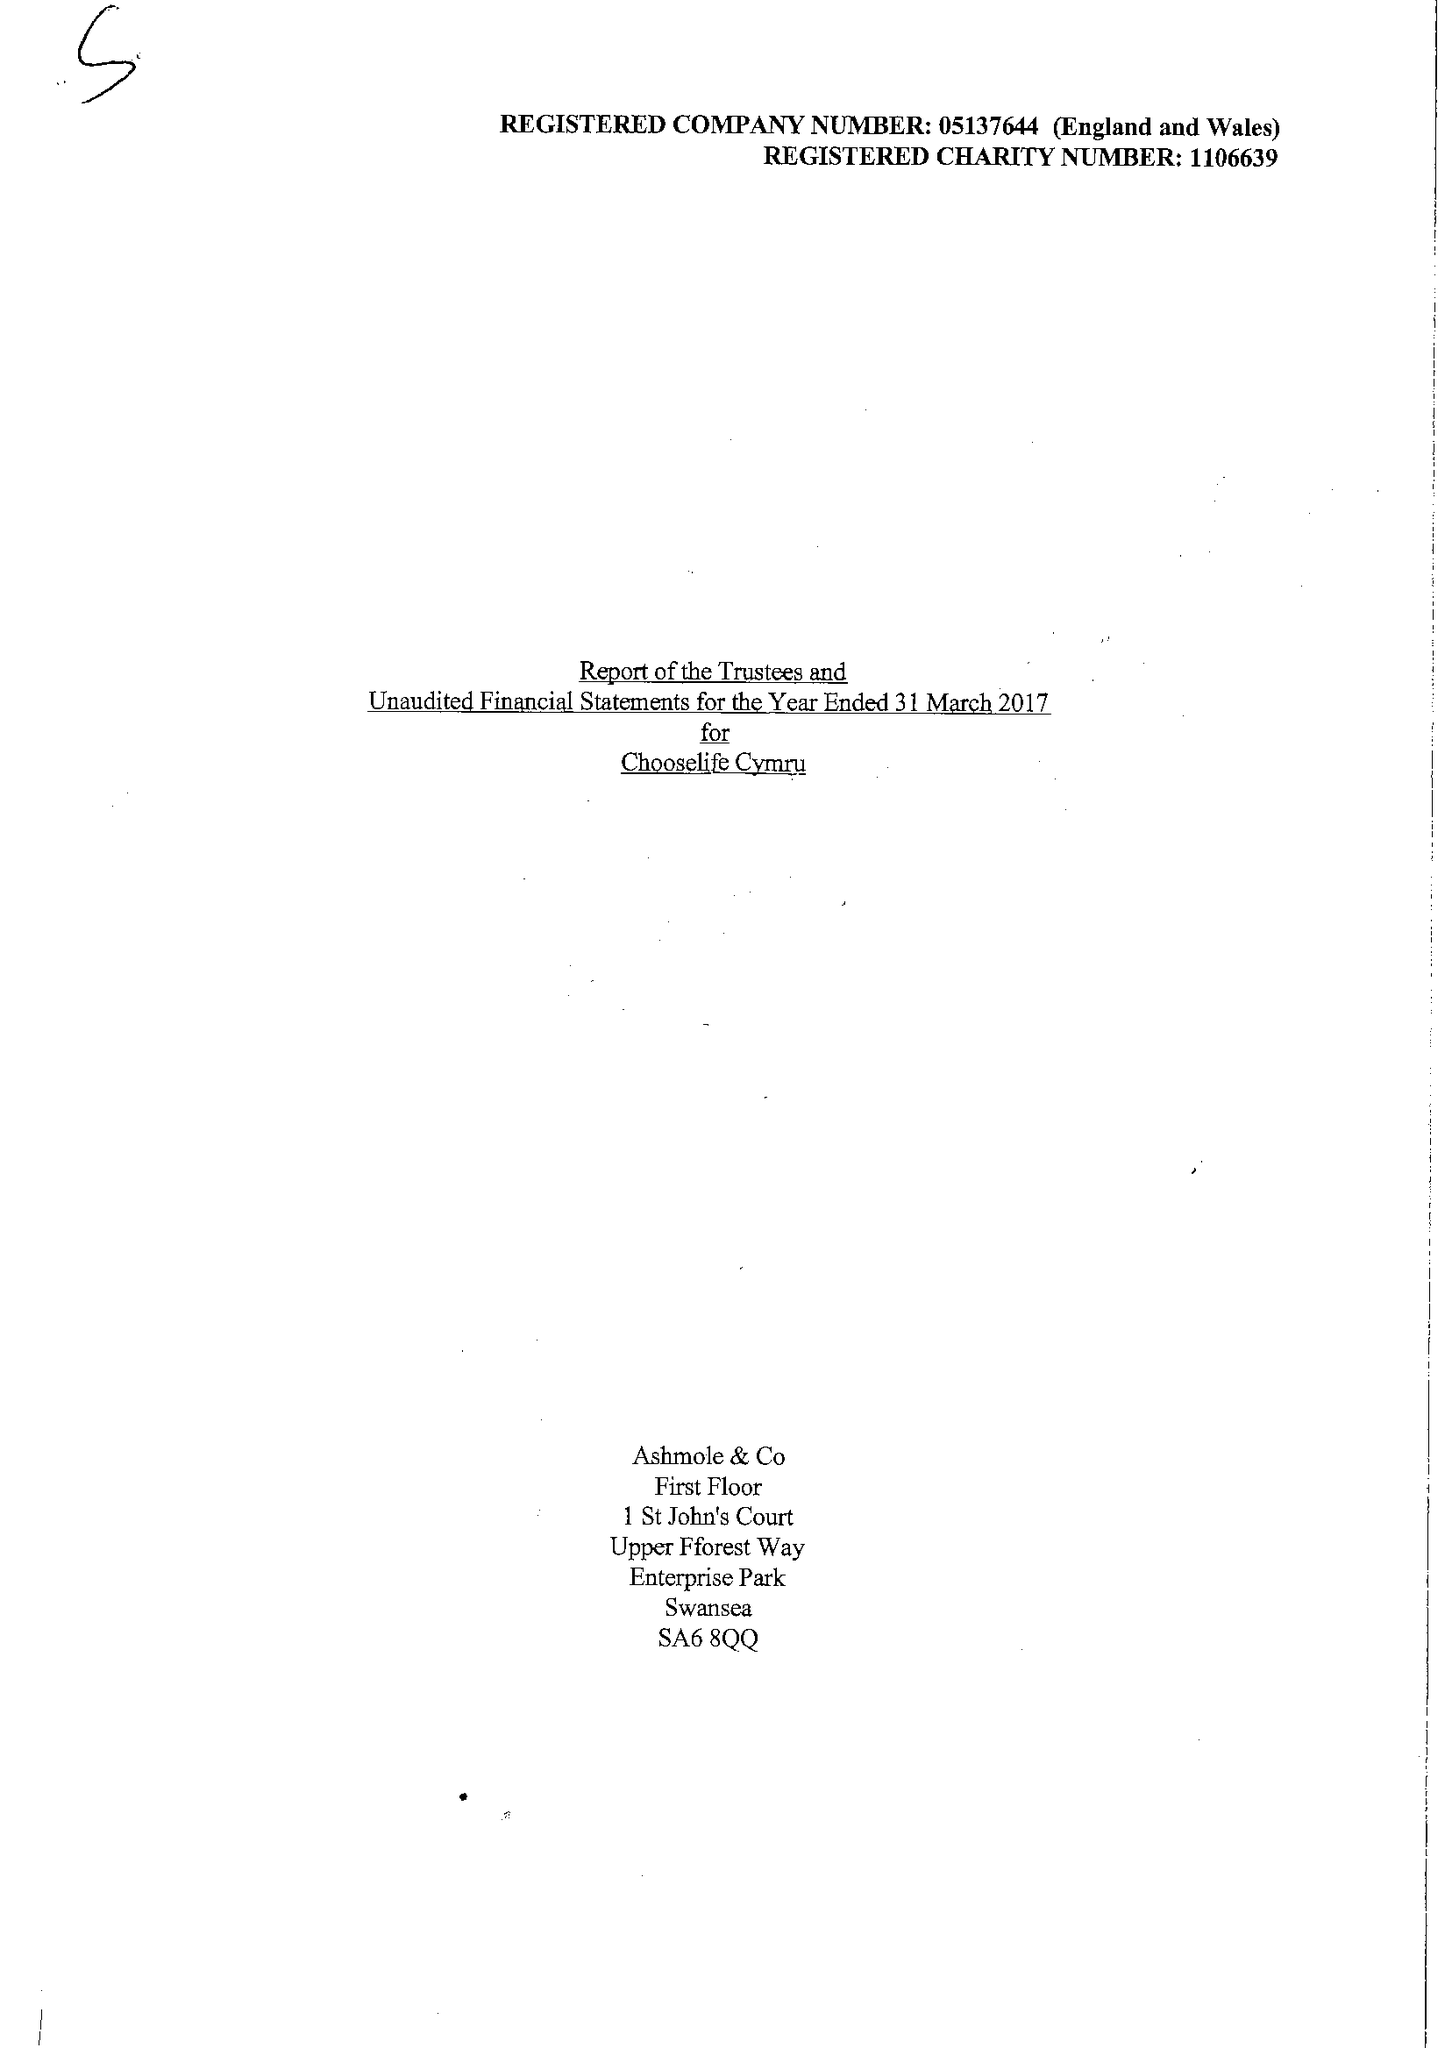What is the value for the address__street_line?
Answer the question using a single word or phrase. COPPERWORKS ROAD 